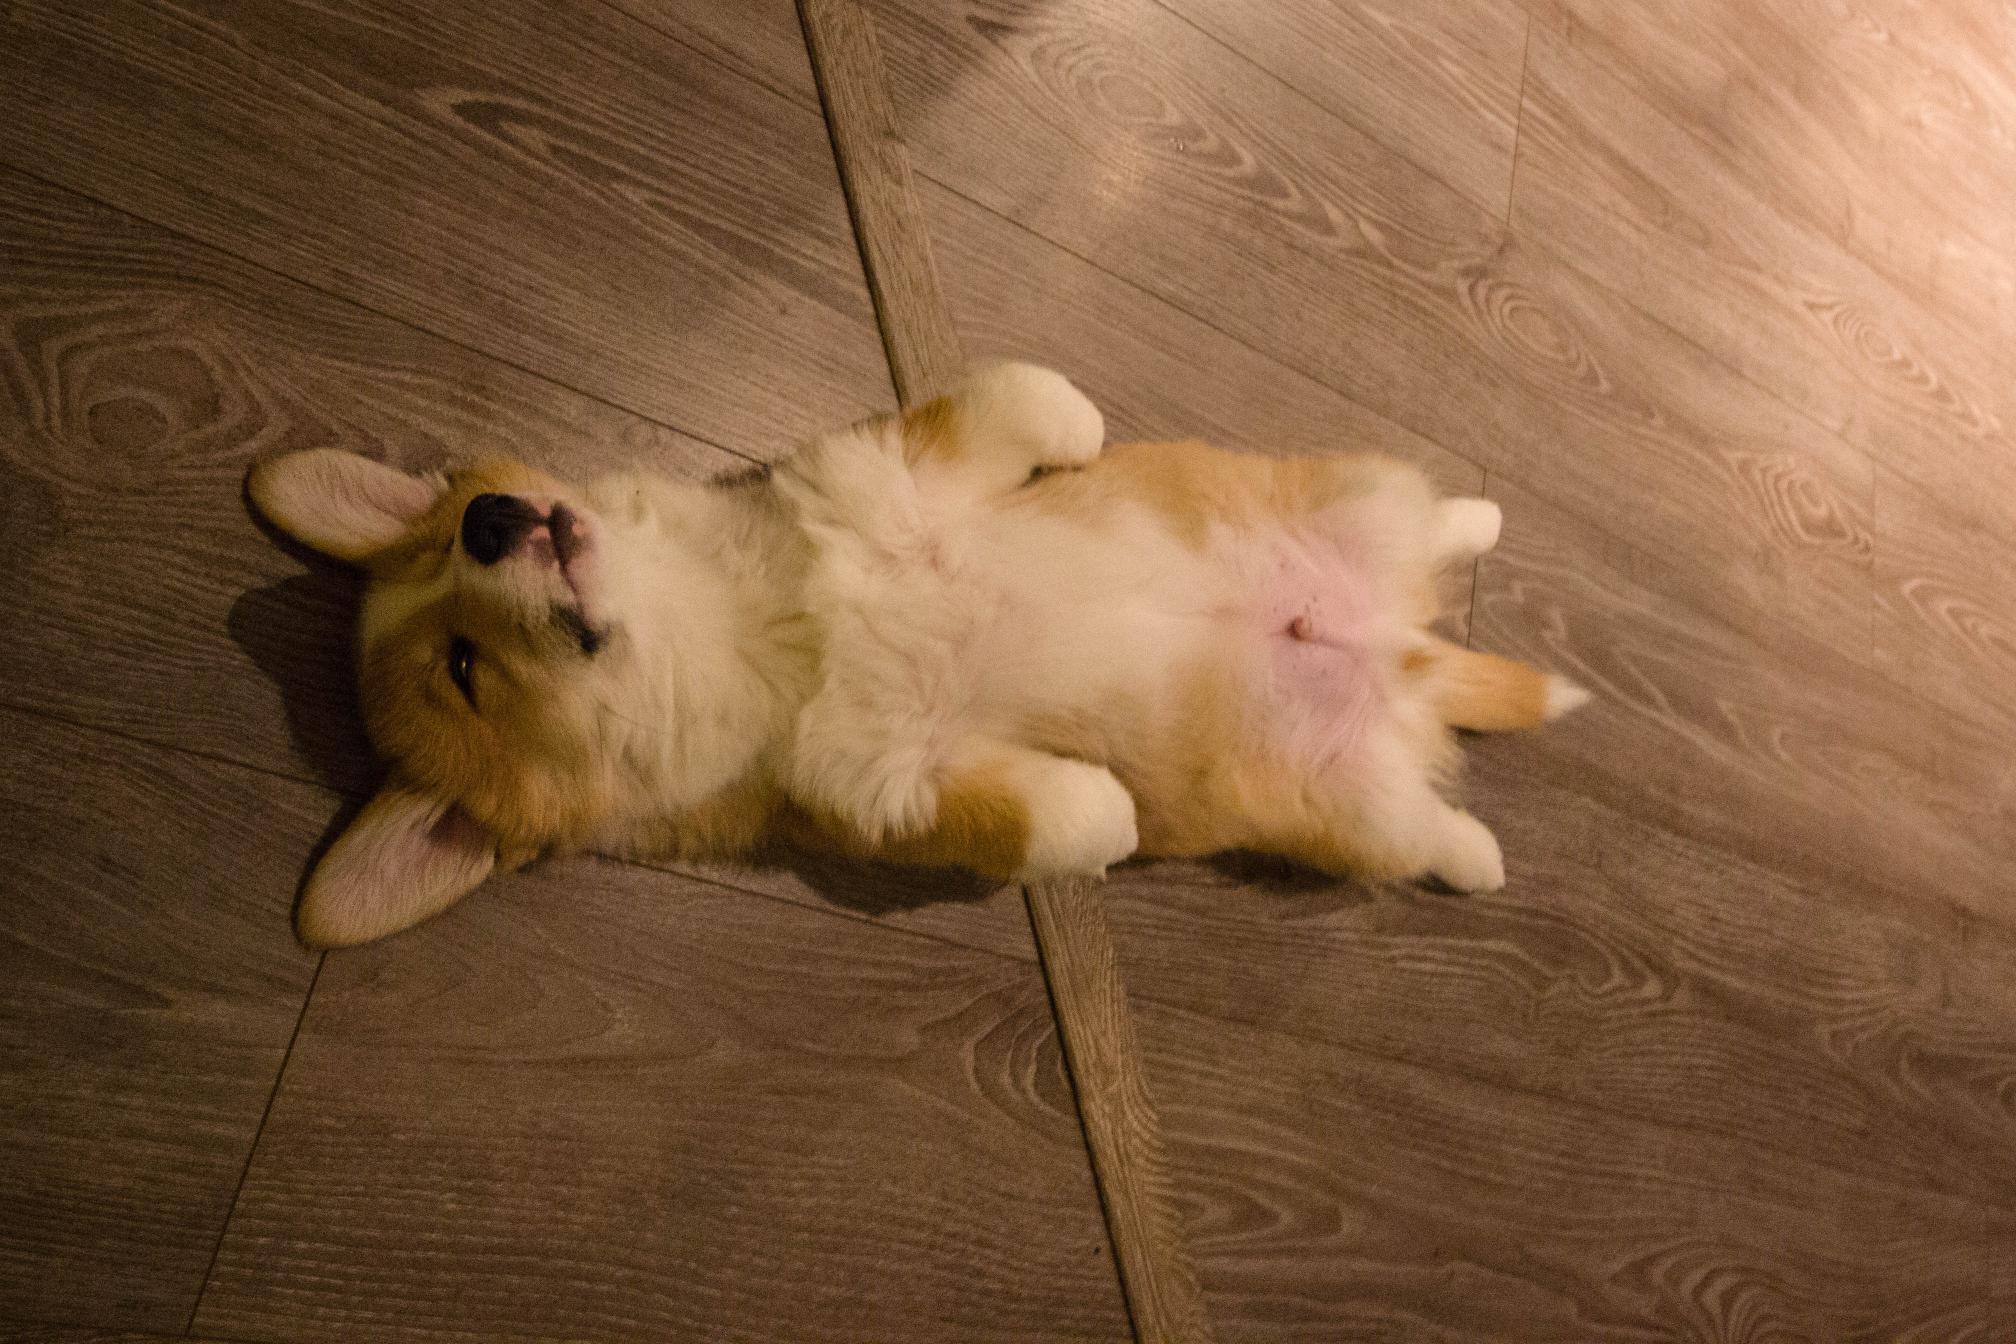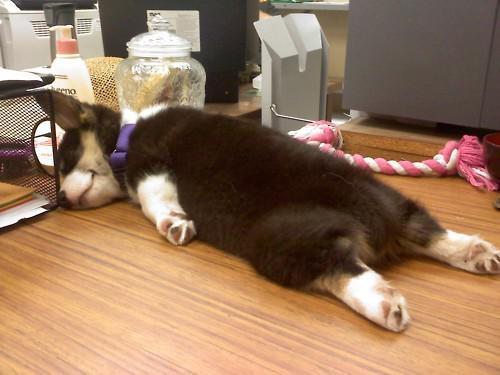The first image is the image on the left, the second image is the image on the right. Evaluate the accuracy of this statement regarding the images: "All corgis are reclining on wood floors, and at least one corgi has its eyes shut.". Is it true? Answer yes or no. Yes. The first image is the image on the left, the second image is the image on the right. Given the left and right images, does the statement "The left image contains a dog that is laying down inside on a wooden floor." hold true? Answer yes or no. Yes. 